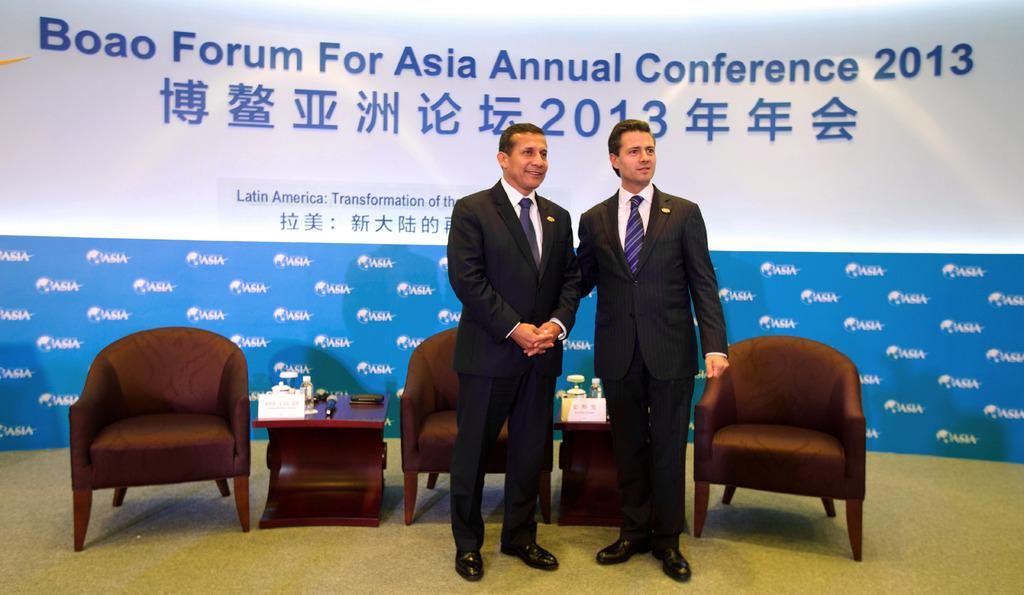What is the general setting of the image? The image depicts a conference setting. How many people are standing in the image? There are two people standing in the image. What can be seen in the background of the image? There are three chairs and two tables in the background. Is there any company-related information visible in the image? Yes, there is a big poster with the name of the company. What type of chin is being used to lead the conference in the image? There is no chin visible in the image, and no one is leading the conference. 